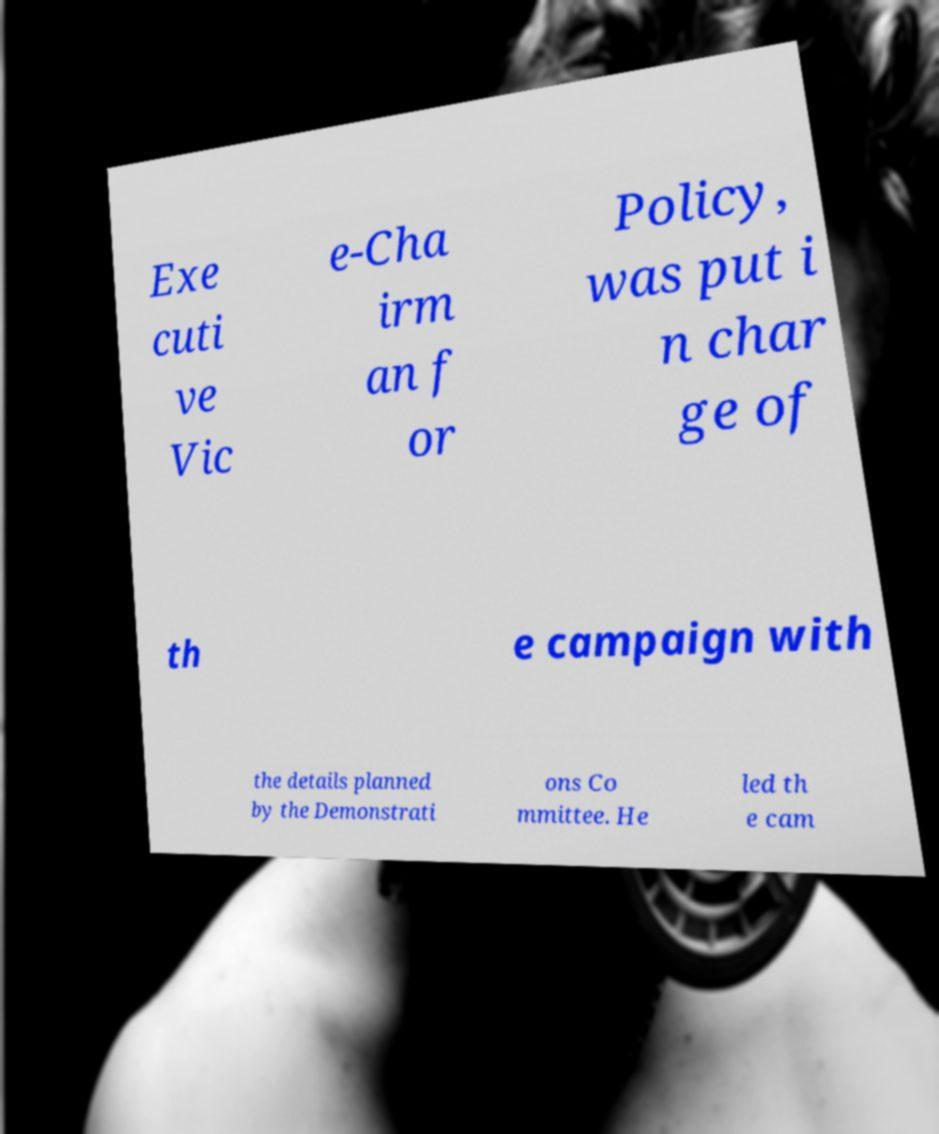Could you extract and type out the text from this image? Exe cuti ve Vic e-Cha irm an f or Policy, was put i n char ge of th e campaign with the details planned by the Demonstrati ons Co mmittee. He led th e cam 